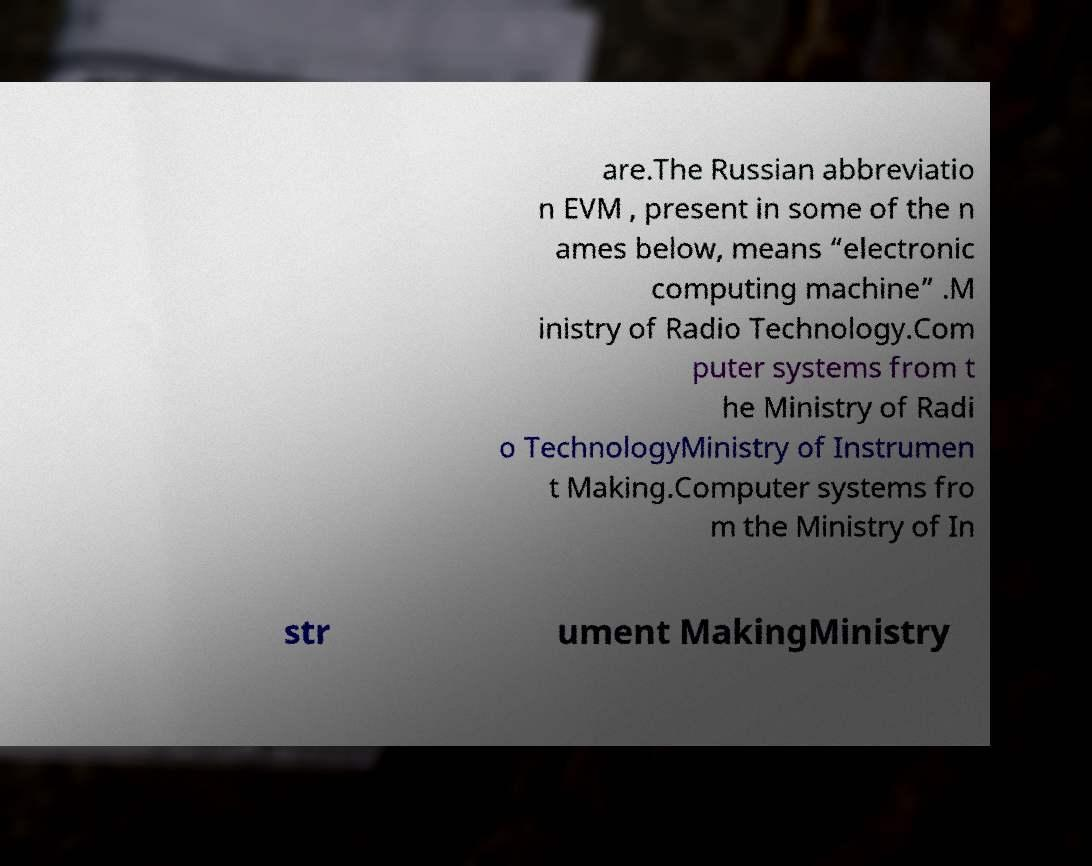Can you read and provide the text displayed in the image?This photo seems to have some interesting text. Can you extract and type it out for me? are.The Russian abbreviatio n EVM , present in some of the n ames below, means “electronic computing machine” .M inistry of Radio Technology.Com puter systems from t he Ministry of Radi o TechnologyMinistry of Instrumen t Making.Computer systems fro m the Ministry of In str ument MakingMinistry 